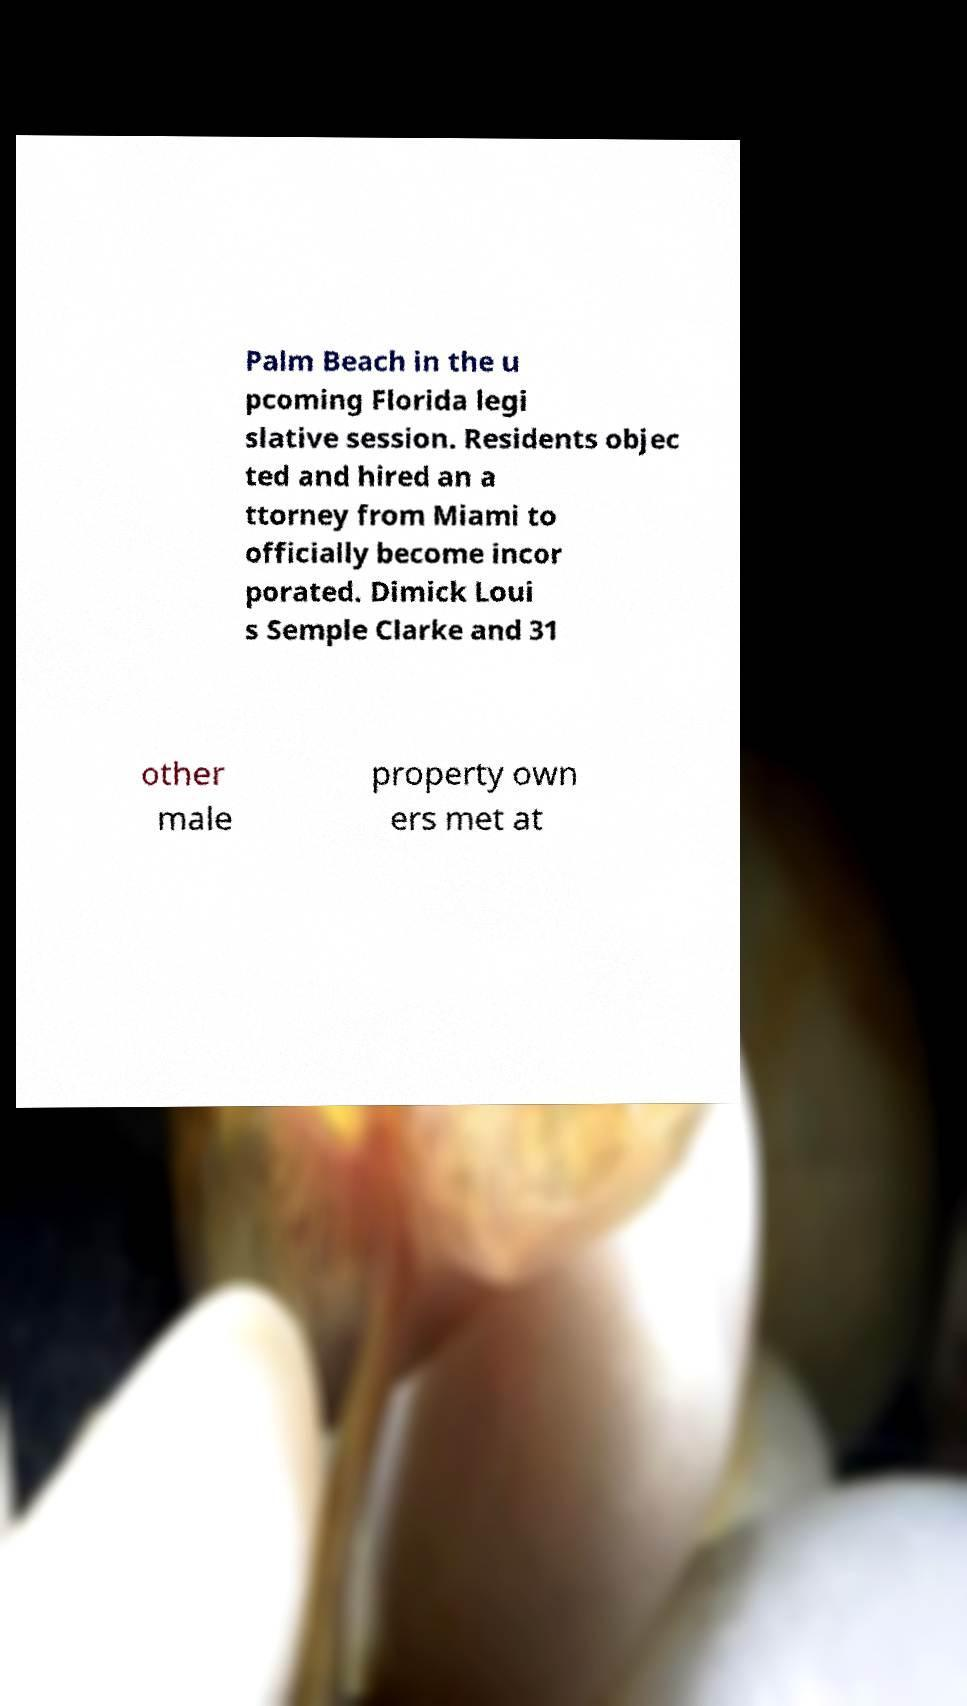Could you assist in decoding the text presented in this image and type it out clearly? Palm Beach in the u pcoming Florida legi slative session. Residents objec ted and hired an a ttorney from Miami to officially become incor porated. Dimick Loui s Semple Clarke and 31 other male property own ers met at 